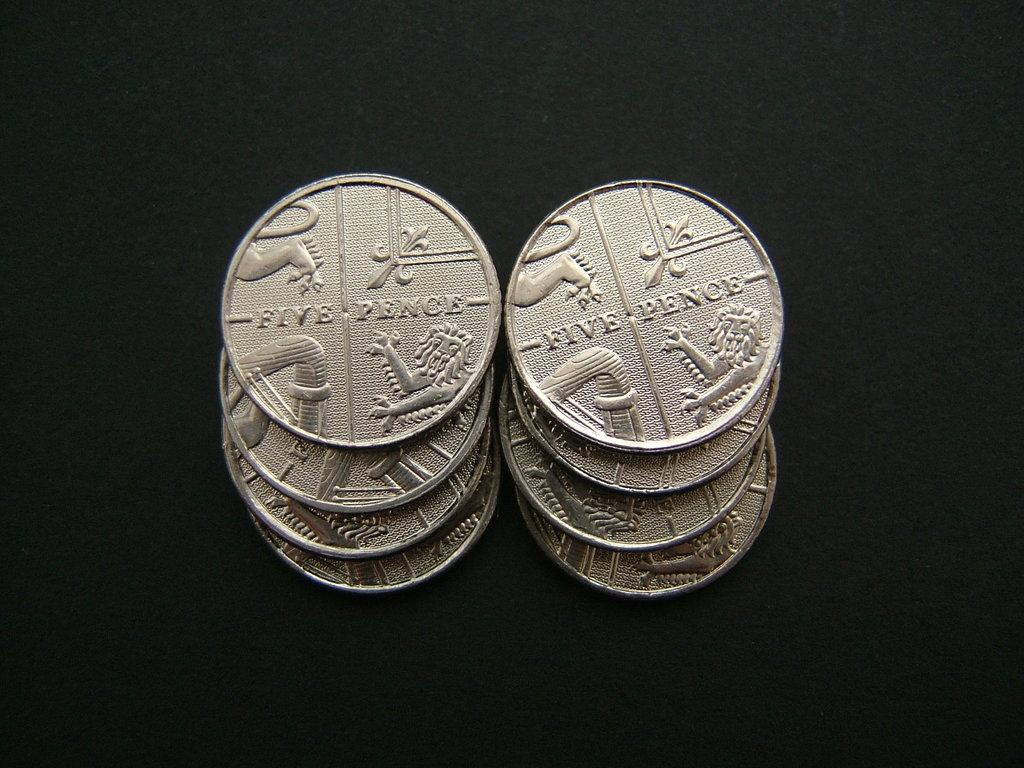<image>
Offer a succinct explanation of the picture presented. The coins that are stacked up have the value of five pence. 